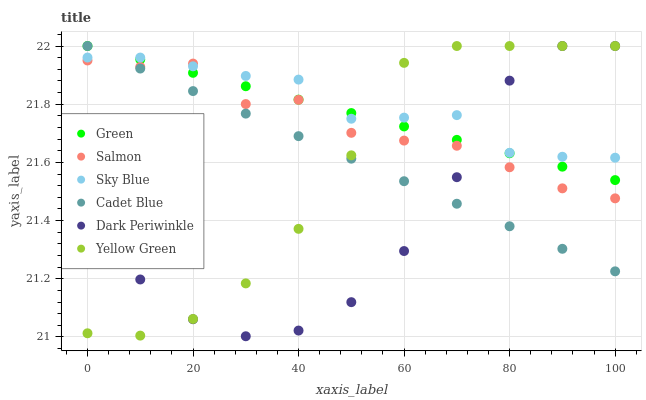Does Dark Periwinkle have the minimum area under the curve?
Answer yes or no. Yes. Does Sky Blue have the maximum area under the curve?
Answer yes or no. Yes. Does Yellow Green have the minimum area under the curve?
Answer yes or no. No. Does Yellow Green have the maximum area under the curve?
Answer yes or no. No. Is Green the smoothest?
Answer yes or no. Yes. Is Dark Periwinkle the roughest?
Answer yes or no. Yes. Is Yellow Green the smoothest?
Answer yes or no. No. Is Yellow Green the roughest?
Answer yes or no. No. Does Dark Periwinkle have the lowest value?
Answer yes or no. Yes. Does Yellow Green have the lowest value?
Answer yes or no. No. Does Dark Periwinkle have the highest value?
Answer yes or no. Yes. Does Salmon have the highest value?
Answer yes or no. No. Does Salmon intersect Sky Blue?
Answer yes or no. Yes. Is Salmon less than Sky Blue?
Answer yes or no. No. Is Salmon greater than Sky Blue?
Answer yes or no. No. 